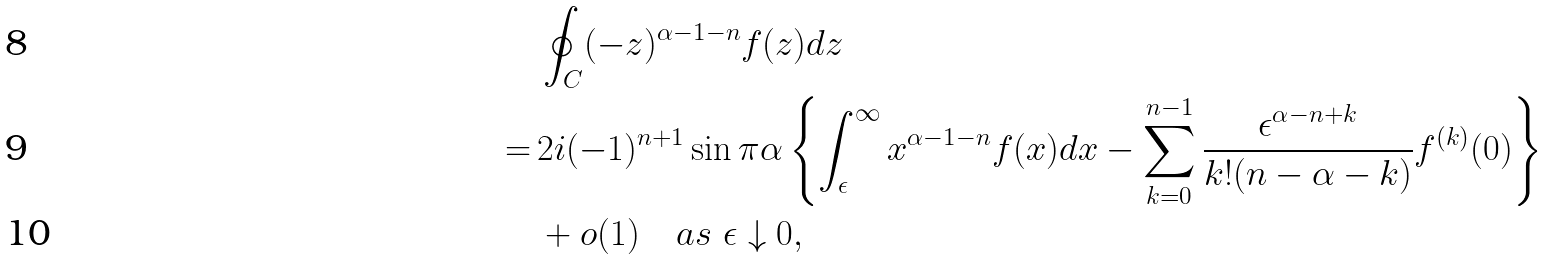<formula> <loc_0><loc_0><loc_500><loc_500>& \oint _ { C } ( - z ) ^ { \alpha - 1 - n } f ( z ) d z \\ = \, & 2 i ( - 1 ) ^ { n + 1 } \sin \pi \alpha \left \{ \int _ { \epsilon } ^ { \infty } x ^ { \alpha - 1 - n } f ( x ) d x - \sum _ { k = 0 } ^ { n - 1 } \frac { \epsilon ^ { \alpha - n + k } } { k ! ( n - \alpha - k ) } f ^ { ( k ) } ( 0 ) \right \} \\ & + o ( 1 ) \quad a s \ \epsilon \downarrow 0 ,</formula> 